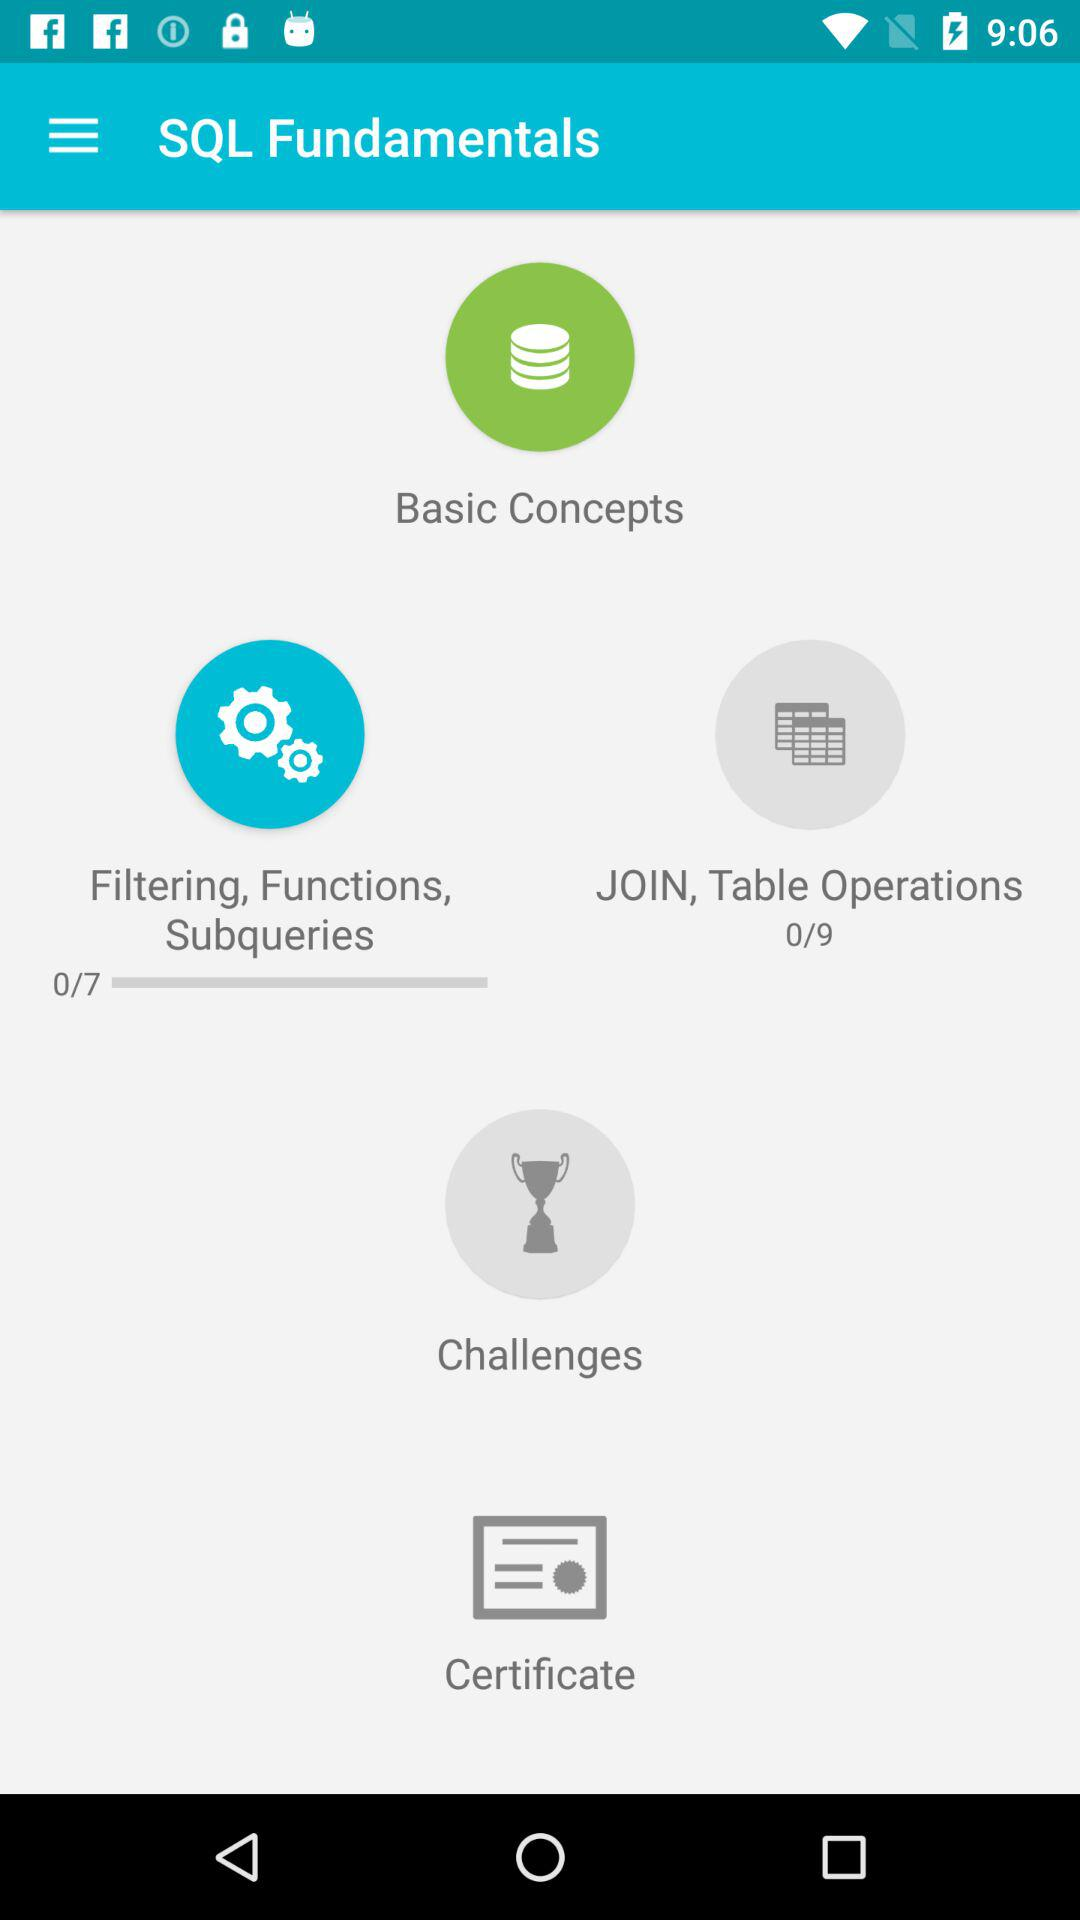How many total tutorials are there for filtering, functions and subqueries in SQL fundamentals? There are 7 total tutorials. 